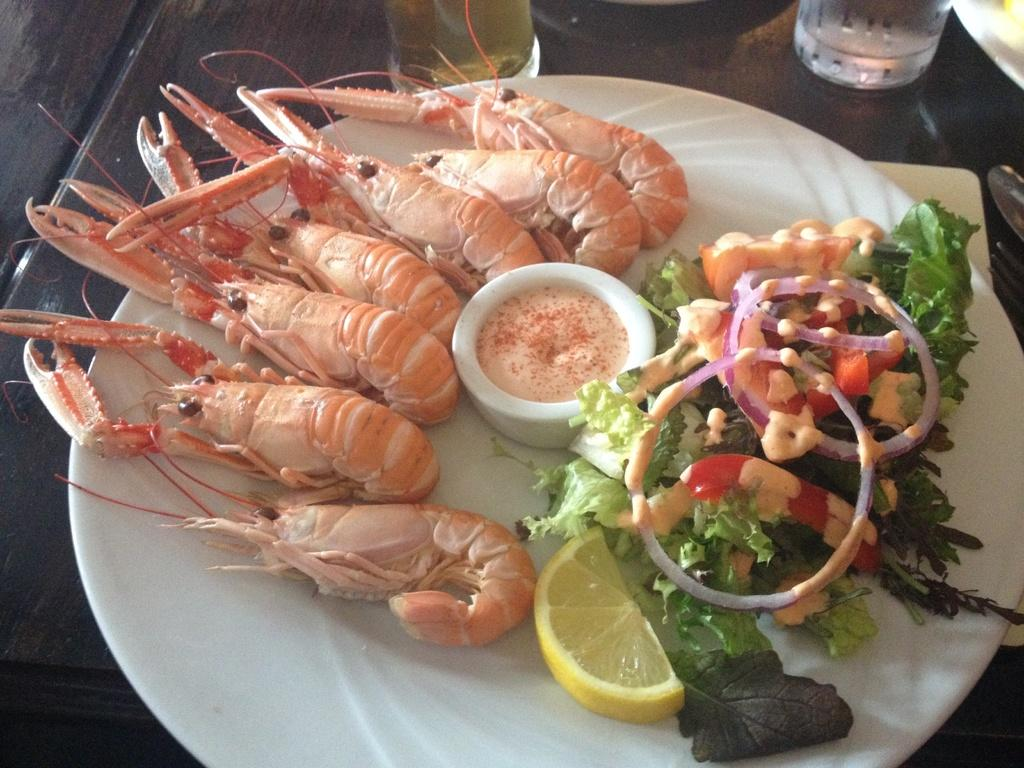What is on the plate that is visible in the image? There is food on a plate in the image. What type of tableware can be seen in the image? There are glasses, a spoon, and a fork in the image. What type of sail can be seen in the image? There is no sail present in the image. What is the size of the uncle in the image? There is no uncle present in the image. 